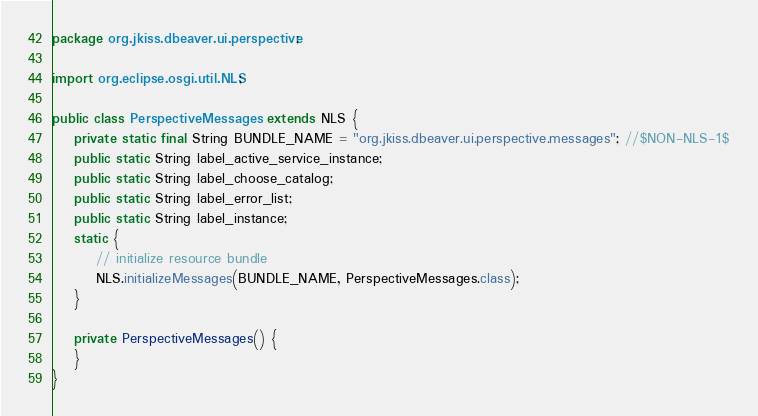Convert code to text. <code><loc_0><loc_0><loc_500><loc_500><_Java_>package org.jkiss.dbeaver.ui.perspective;

import org.eclipse.osgi.util.NLS;

public class PerspectiveMessages extends NLS {
	private static final String BUNDLE_NAME = "org.jkiss.dbeaver.ui.perspective.messages"; //$NON-NLS-1$
	public static String label_active_service_instance;
	public static String label_choose_catalog;
	public static String label_error_list;
	public static String label_instance;
	static {
		// initialize resource bundle
		NLS.initializeMessages(BUNDLE_NAME, PerspectiveMessages.class);
	}

	private PerspectiveMessages() {
	}
}
</code> 